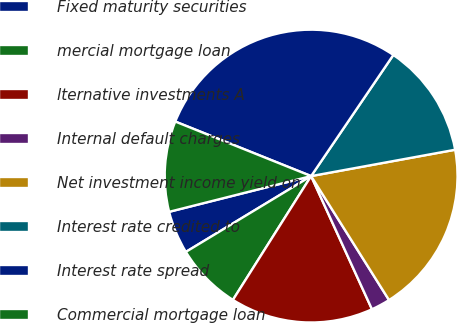<chart> <loc_0><loc_0><loc_500><loc_500><pie_chart><fcel>Fixed maturity securities<fcel>mercial mortgage loan<fcel>lternative investments A<fcel>Internal default charges<fcel>Net investment income yield on<fcel>Interest rate credited to<fcel>Interest rate spread<fcel>Commercial mortgage loan<nl><fcel>4.74%<fcel>7.37%<fcel>15.79%<fcel>2.11%<fcel>18.95%<fcel>12.63%<fcel>28.42%<fcel>10.0%<nl></chart> 